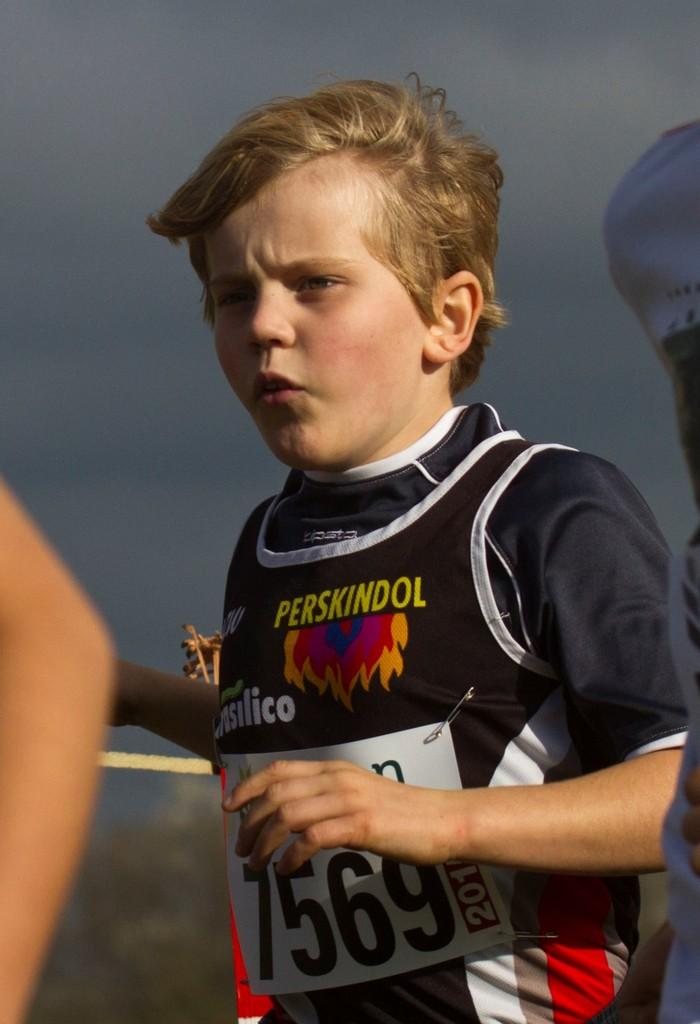<image>
Create a compact narrative representing the image presented. A young boy with the number 7569 running in a marathon. 